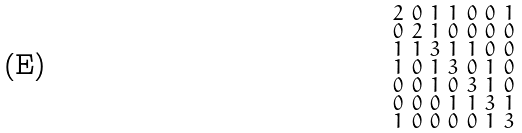Convert formula to latex. <formula><loc_0><loc_0><loc_500><loc_500>\begin{smallmatrix} 2 & 0 & 1 & 1 & 0 & 0 & 1 \\ 0 & 2 & 1 & 0 & 0 & 0 & 0 \\ 1 & 1 & 3 & 1 & 1 & 0 & 0 \\ 1 & 0 & 1 & 3 & 0 & 1 & 0 \\ 0 & 0 & 1 & 0 & 3 & 1 & 0 \\ 0 & 0 & 0 & 1 & 1 & 3 & 1 \\ 1 & 0 & 0 & 0 & 0 & 1 & 3 \end{smallmatrix}</formula> 